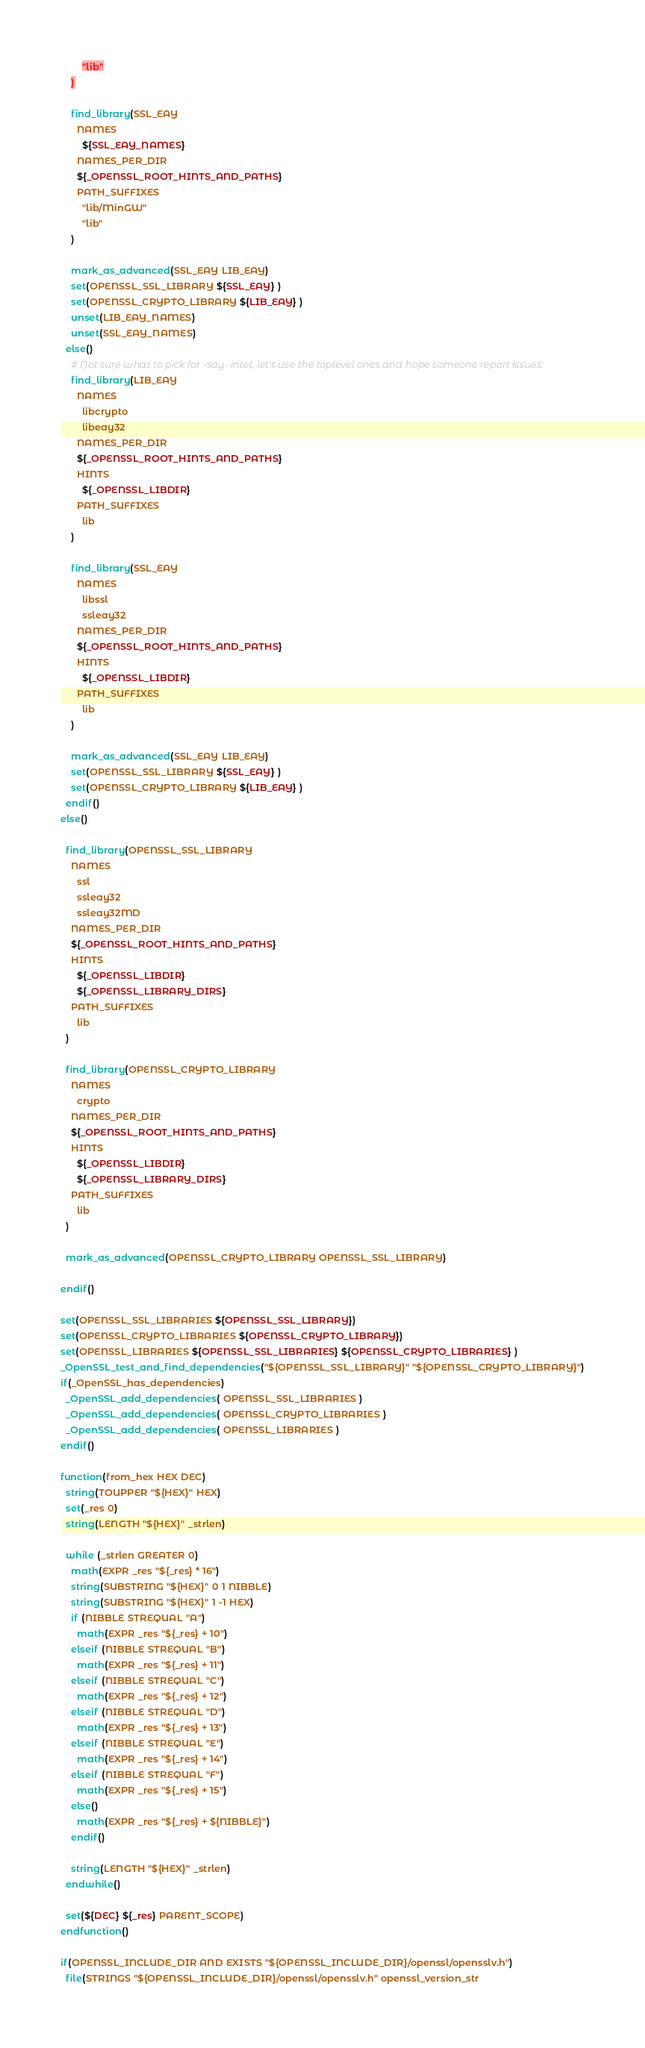<code> <loc_0><loc_0><loc_500><loc_500><_CMake_>        "lib"
    )

    find_library(SSL_EAY
      NAMES
        ${SSL_EAY_NAMES}
      NAMES_PER_DIR
      ${_OPENSSL_ROOT_HINTS_AND_PATHS}
      PATH_SUFFIXES
        "lib/MinGW"
        "lib"
    )

    mark_as_advanced(SSL_EAY LIB_EAY)
    set(OPENSSL_SSL_LIBRARY ${SSL_EAY} )
    set(OPENSSL_CRYPTO_LIBRARY ${LIB_EAY} )
    unset(LIB_EAY_NAMES)
    unset(SSL_EAY_NAMES)
  else()
    # Not sure what to pick for -say- intel, let's use the toplevel ones and hope someone report issues:
    find_library(LIB_EAY
      NAMES
        libcrypto
        libeay32
      NAMES_PER_DIR
      ${_OPENSSL_ROOT_HINTS_AND_PATHS}
      HINTS
        ${_OPENSSL_LIBDIR}
      PATH_SUFFIXES
        lib
    )

    find_library(SSL_EAY
      NAMES
        libssl
        ssleay32
      NAMES_PER_DIR
      ${_OPENSSL_ROOT_HINTS_AND_PATHS}
      HINTS
        ${_OPENSSL_LIBDIR}
      PATH_SUFFIXES
        lib
    )

    mark_as_advanced(SSL_EAY LIB_EAY)
    set(OPENSSL_SSL_LIBRARY ${SSL_EAY} )
    set(OPENSSL_CRYPTO_LIBRARY ${LIB_EAY} )
  endif()
else()

  find_library(OPENSSL_SSL_LIBRARY
    NAMES
      ssl
      ssleay32
      ssleay32MD
    NAMES_PER_DIR
    ${_OPENSSL_ROOT_HINTS_AND_PATHS}
    HINTS
      ${_OPENSSL_LIBDIR}
      ${_OPENSSL_LIBRARY_DIRS}
    PATH_SUFFIXES
      lib
  )

  find_library(OPENSSL_CRYPTO_LIBRARY
    NAMES
      crypto
    NAMES_PER_DIR
    ${_OPENSSL_ROOT_HINTS_AND_PATHS}
    HINTS
      ${_OPENSSL_LIBDIR}
      ${_OPENSSL_LIBRARY_DIRS}
    PATH_SUFFIXES
      lib
  )

  mark_as_advanced(OPENSSL_CRYPTO_LIBRARY OPENSSL_SSL_LIBRARY)

endif()

set(OPENSSL_SSL_LIBRARIES ${OPENSSL_SSL_LIBRARY})
set(OPENSSL_CRYPTO_LIBRARIES ${OPENSSL_CRYPTO_LIBRARY})
set(OPENSSL_LIBRARIES ${OPENSSL_SSL_LIBRARIES} ${OPENSSL_CRYPTO_LIBRARIES} )
_OpenSSL_test_and_find_dependencies("${OPENSSL_SSL_LIBRARY}" "${OPENSSL_CRYPTO_LIBRARY}")
if(_OpenSSL_has_dependencies)
  _OpenSSL_add_dependencies( OPENSSL_SSL_LIBRARIES )
  _OpenSSL_add_dependencies( OPENSSL_CRYPTO_LIBRARIES )
  _OpenSSL_add_dependencies( OPENSSL_LIBRARIES )
endif()

function(from_hex HEX DEC)
  string(TOUPPER "${HEX}" HEX)
  set(_res 0)
  string(LENGTH "${HEX}" _strlen)

  while (_strlen GREATER 0)
    math(EXPR _res "${_res} * 16")
    string(SUBSTRING "${HEX}" 0 1 NIBBLE)
    string(SUBSTRING "${HEX}" 1 -1 HEX)
    if (NIBBLE STREQUAL "A")
      math(EXPR _res "${_res} + 10")
    elseif (NIBBLE STREQUAL "B")
      math(EXPR _res "${_res} + 11")
    elseif (NIBBLE STREQUAL "C")
      math(EXPR _res "${_res} + 12")
    elseif (NIBBLE STREQUAL "D")
      math(EXPR _res "${_res} + 13")
    elseif (NIBBLE STREQUAL "E")
      math(EXPR _res "${_res} + 14")
    elseif (NIBBLE STREQUAL "F")
      math(EXPR _res "${_res} + 15")
    else()
      math(EXPR _res "${_res} + ${NIBBLE}")
    endif()

    string(LENGTH "${HEX}" _strlen)
  endwhile()

  set(${DEC} ${_res} PARENT_SCOPE)
endfunction()

if(OPENSSL_INCLUDE_DIR AND EXISTS "${OPENSSL_INCLUDE_DIR}/openssl/opensslv.h")
  file(STRINGS "${OPENSSL_INCLUDE_DIR}/openssl/opensslv.h" openssl_version_str</code> 